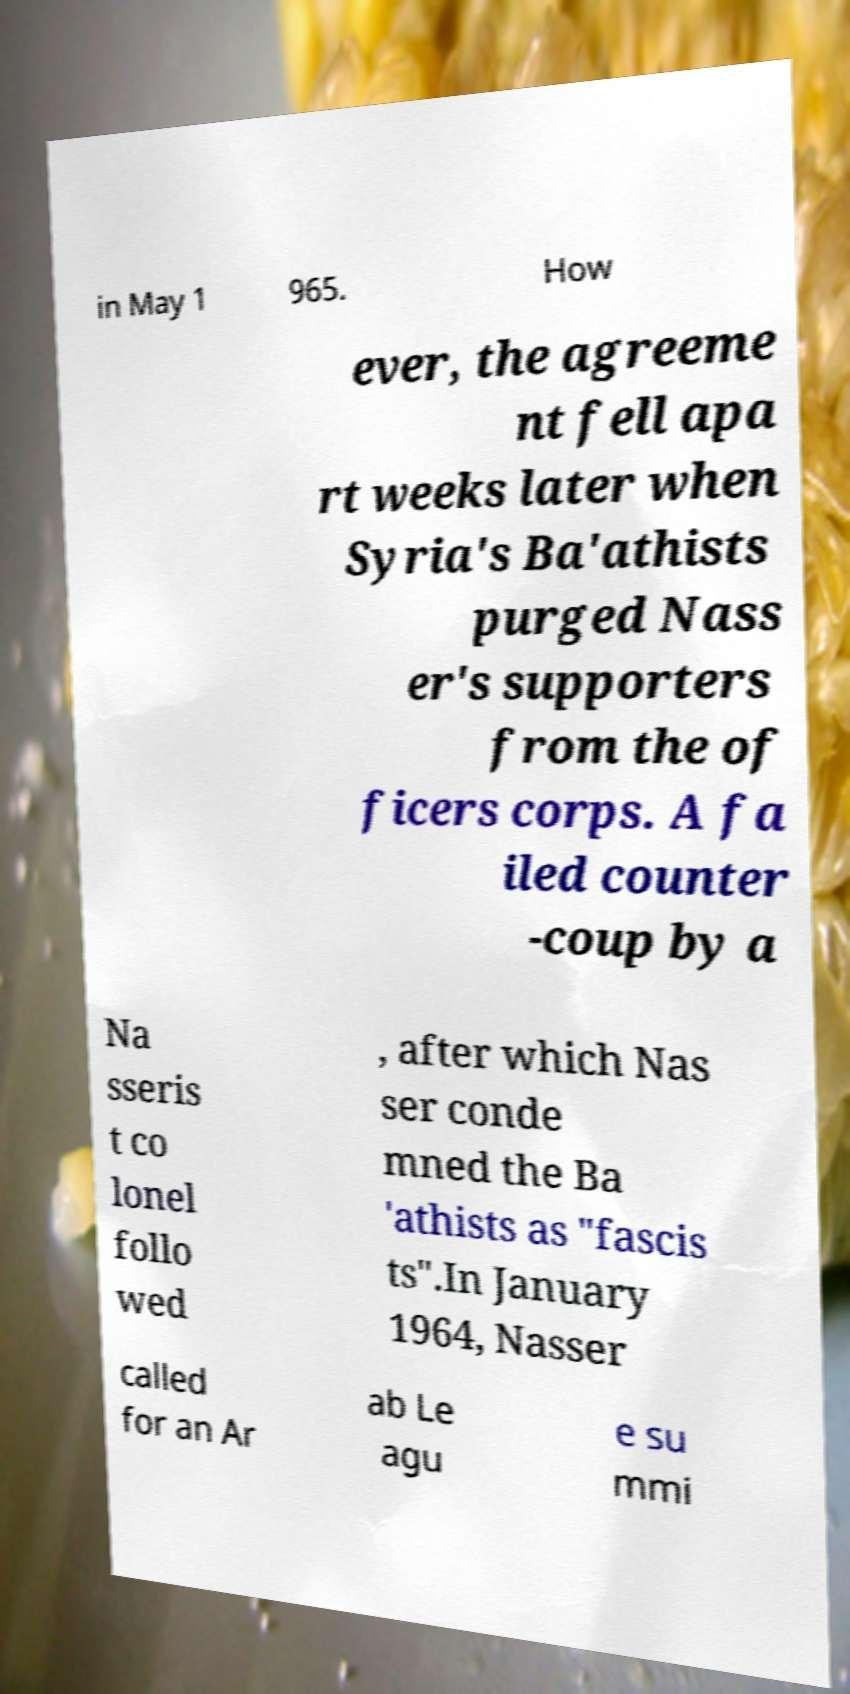Please identify and transcribe the text found in this image. in May 1 965. How ever, the agreeme nt fell apa rt weeks later when Syria's Ba'athists purged Nass er's supporters from the of ficers corps. A fa iled counter -coup by a Na sseris t co lonel follo wed , after which Nas ser conde mned the Ba 'athists as "fascis ts".In January 1964, Nasser called for an Ar ab Le agu e su mmi 